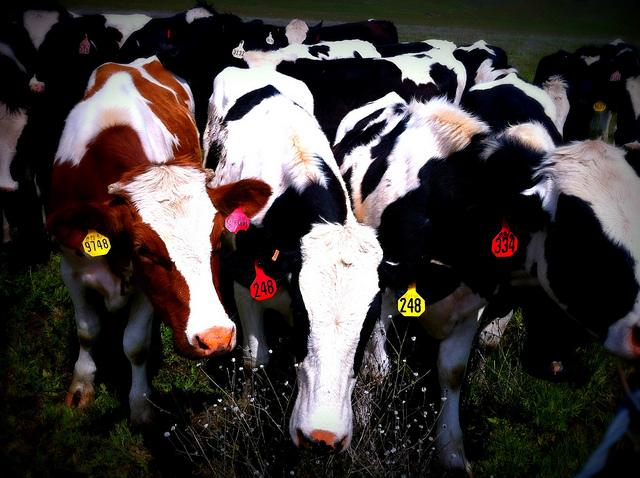What is the largest number on the yellow tags?

Choices:
A) 778
B) 403
C) 10562
D) 9748 9748 